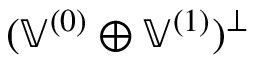Convert formula to latex. <formula><loc_0><loc_0><loc_500><loc_500>( \mathbb { V } ^ { ( 0 ) } \oplus \mathbb { V } ^ { ( 1 ) } ) ^ { \perp }</formula> 